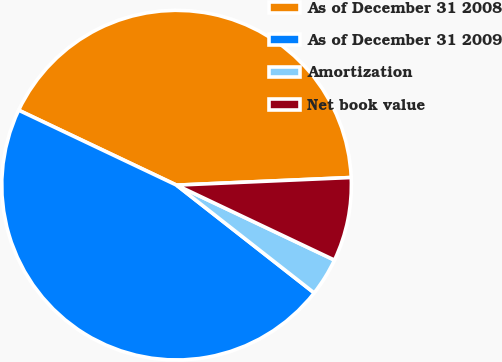Convert chart to OTSL. <chart><loc_0><loc_0><loc_500><loc_500><pie_chart><fcel>As of December 31 2008<fcel>As of December 31 2009<fcel>Amortization<fcel>Net book value<nl><fcel>42.25%<fcel>46.48%<fcel>3.52%<fcel>7.75%<nl></chart> 